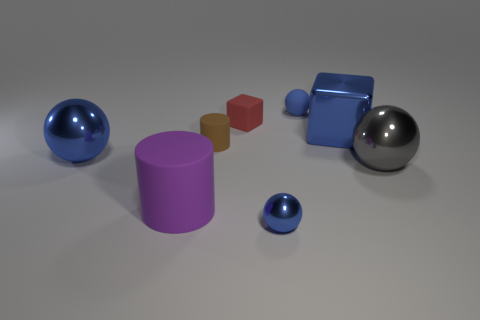Subtract all blue spheres. How many were subtracted if there are1blue spheres left? 2 Subtract all gray shiny spheres. How many spheres are left? 3 Subtract 1 spheres. How many spheres are left? 3 Add 1 small shiny things. How many objects exist? 9 Subtract all blue cubes. How many blue balls are left? 3 Subtract all gray spheres. How many spheres are left? 3 Subtract all cylinders. How many objects are left? 6 Subtract 0 yellow balls. How many objects are left? 8 Subtract all purple balls. Subtract all green cylinders. How many balls are left? 4 Subtract all tiny purple shiny objects. Subtract all shiny things. How many objects are left? 4 